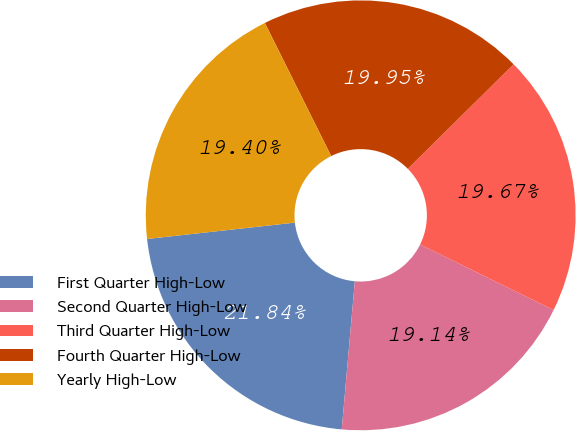Convert chart. <chart><loc_0><loc_0><loc_500><loc_500><pie_chart><fcel>First Quarter High-Low<fcel>Second Quarter High-Low<fcel>Third Quarter High-Low<fcel>Fourth Quarter High-Low<fcel>Yearly High-Low<nl><fcel>21.84%<fcel>19.14%<fcel>19.67%<fcel>19.95%<fcel>19.4%<nl></chart> 